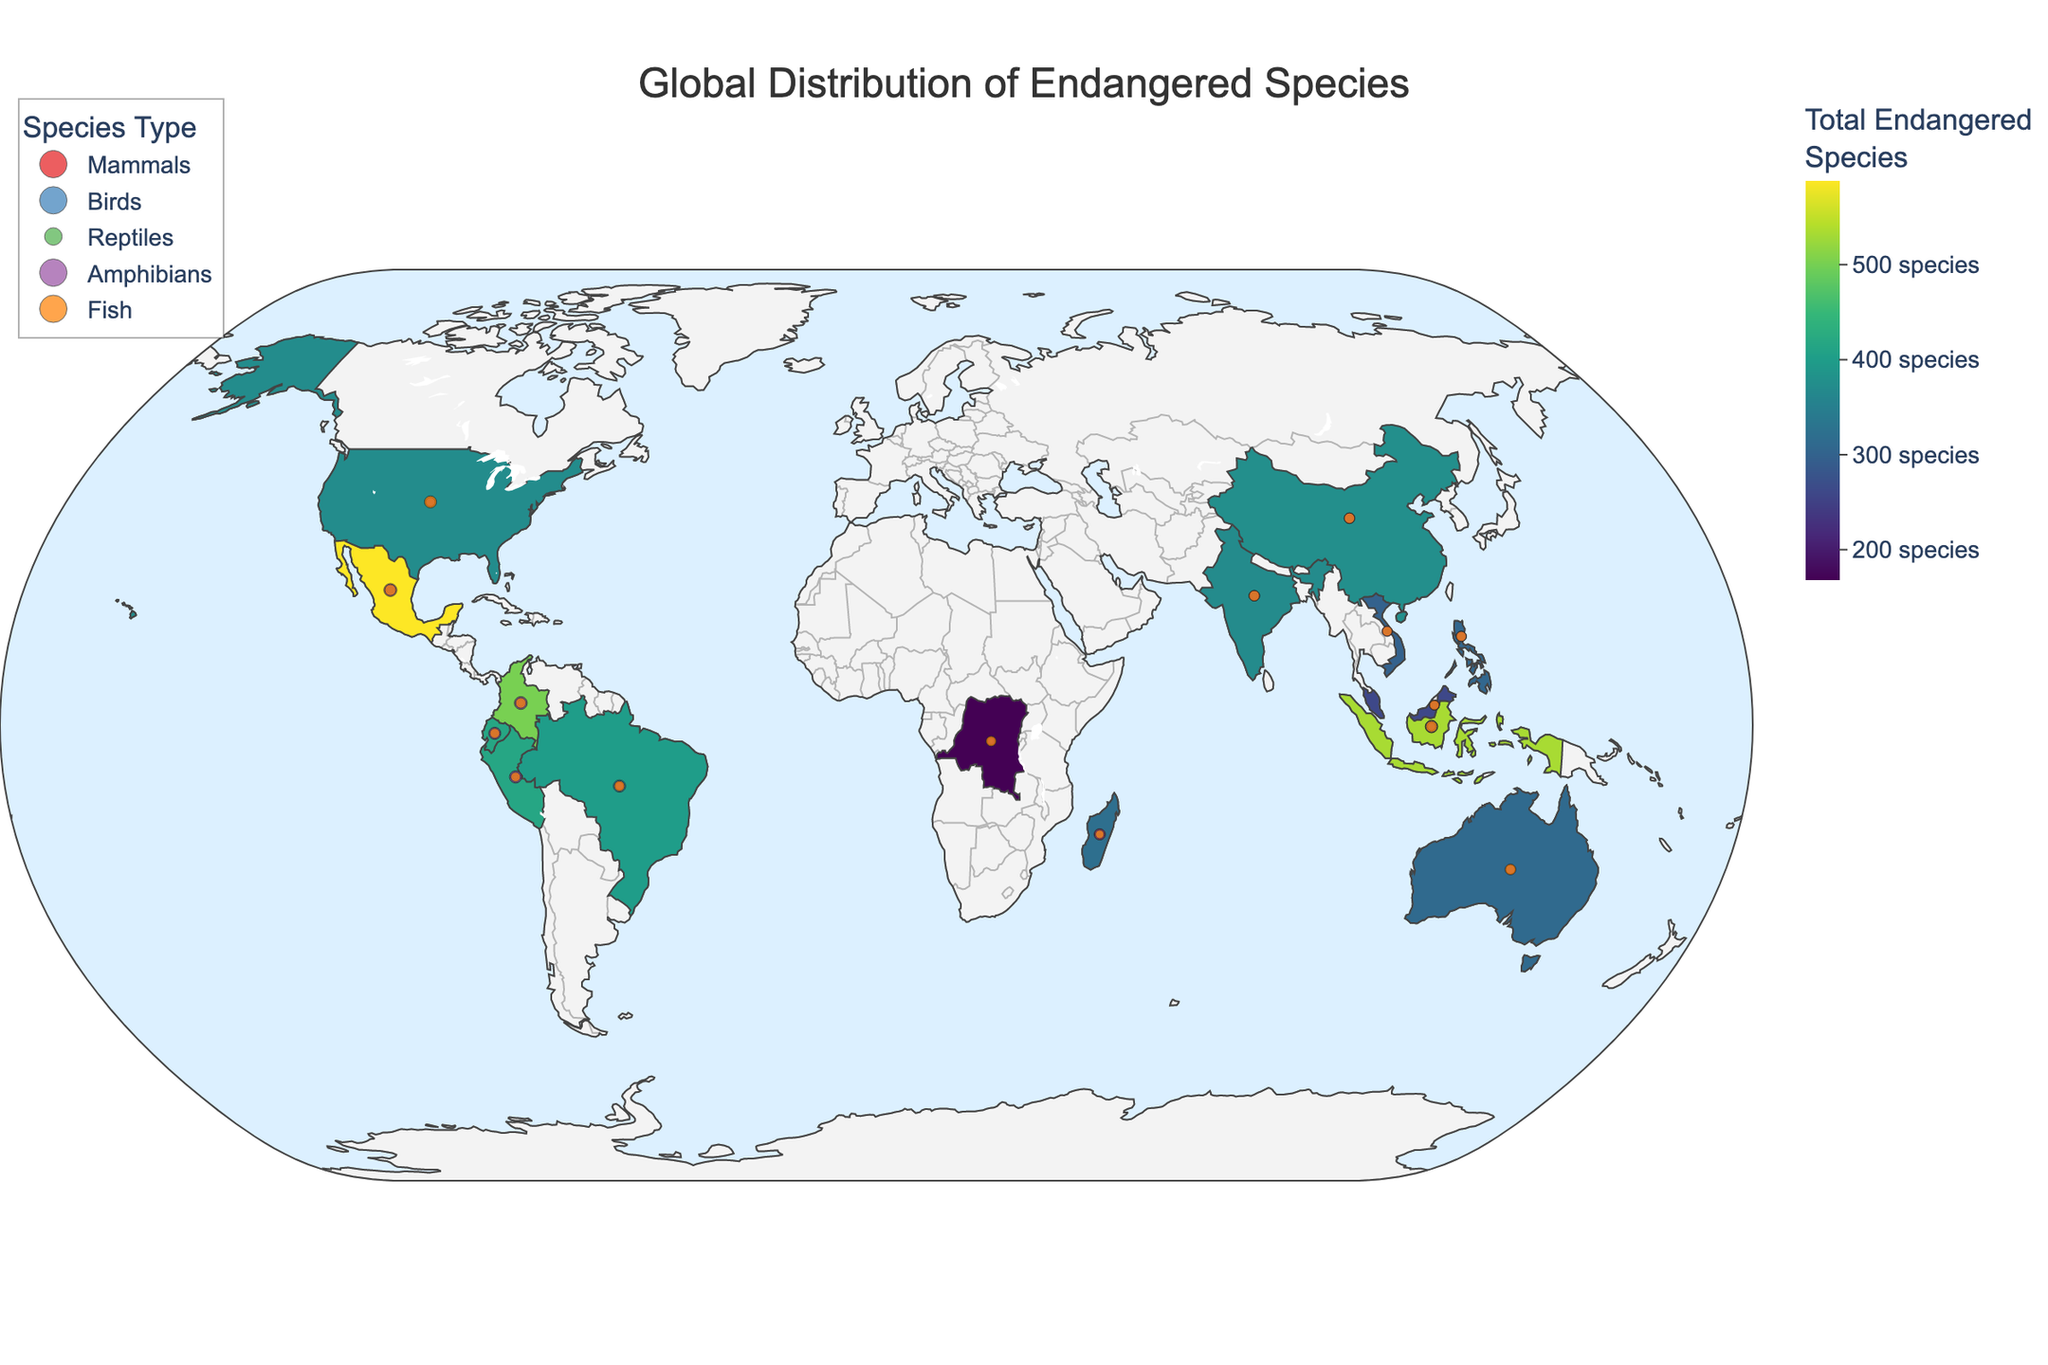What is the title of the figure? The title is displayed at the top of the figure, showing what the chart is about.
Answer: Global Distribution of Endangered Species Which country has the highest number of total endangered species? Look for the country with the darkest color on the map, which indicates the highest number. From the data, Indonesia has the highest number with 533 total endangered species.
Answer: Indonesia How many endangered mammals are in Brazil? Hover over Brazil on the map to see the number of endangered mammals. The tooltip for Brazil shows that it has 80 endangered mammals.
Answer: 80 Which country has the fewest endangered reptiles? Identify the country with the least intense color for reptiles. The data shows that the Democratic Republic of Congo has the fewest endangered reptiles, with only 2.
Answer: Democratic Republic of Congo What is the total number of endangered species in Australia? Hovering over Australia shows the sum of all endangered species categories. The data indicates Australia has a total of 312 endangered species.
Answer: 312 Compare the number of endangered amphibians in China to those in Madagascar. Which has more? Look at the circle sizes for amphibians on China and Madagascar or refer to the data directly. China has 87 endangered amphibians, and Madagascar has 104. So, Madagascar has more.
Answer: Madagascar Which region has a higher count of endangered birds, Brazil or Colombia? Hovering over Brazil and Colombia on the map will show the number of endangered birds. Brazil has 175 endangered birds, while Colombia has 126. Thus, Brazil has more.
Answer: Brazil What is the average number of endangered fish in the listed countries? Sum the endangered fish across all countries: (163 + 86 + 120 + 103 + 92 + 43 + 117 + 94 + 87 + 62 + 80 + 77 + 68 + 73 + 70) = 1335. Divide by the number of countries (15) to get the average: 1335 / 15 = 89.
Answer: 89 Identify the country with the third highest number of endangered mammals. From the data, sort the countries by the number of endangered mammals. The third highest is Madagascar with 120 endangered mammals, following Indonesia (185) and Brazil (80).
Answer: Madagascar Which five countries have the most endangered species in total? Sum the total endangered species for all countries and then rank them. The top five countries are Indonesia (533), Mexico (588), Colombia (501), Peru (417), and China (376).
Answer: Indonesia, Mexico, Colombia, Peru, China 